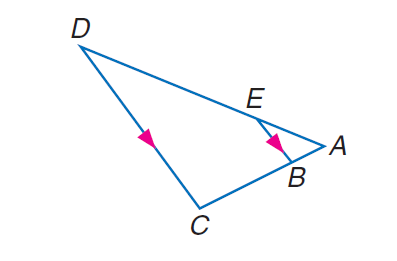Answer the mathemtical geometry problem and directly provide the correct option letter.
Question: Find E D if A E = 3, A B = 2, B C = 6, and E D = 2 x - 3.
Choices: A: 5 B: 6 C: 8 D: 9 D 